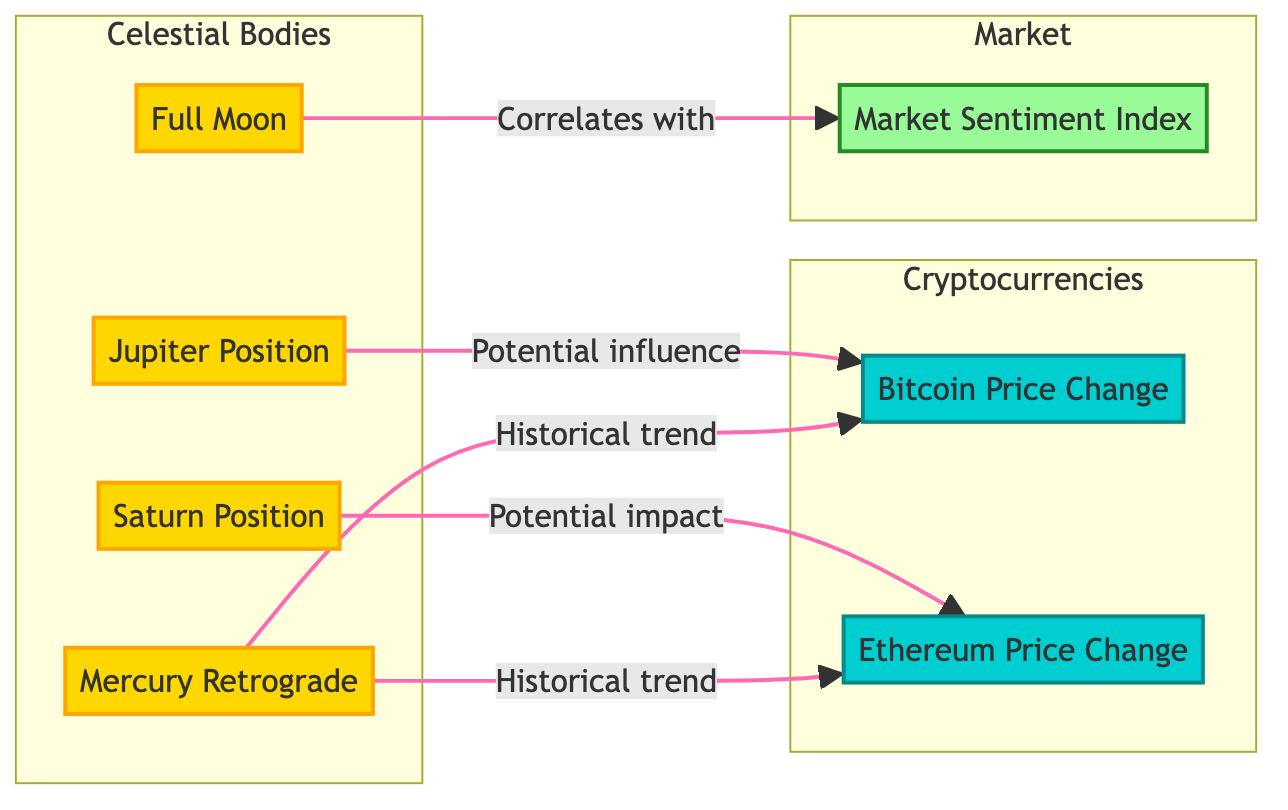What celestial body is linked to Bitcoin price change? The diagram shows an arrow from Jupiter Position to Bitcoin Price Change, indicating a potential influence.
Answer: Jupiter Position What is the major factor that correlates with the Market Sentiment Index? The diagram presents a correlation arrow from Full Moon to Market Sentiment Index, suggesting the relationship.
Answer: Full Moon How many celestial bodies are represented in the diagram? The diagram contains four distinct celestial bodies: Jupiter Position, Saturn Position, Full Moon, and Mercury Retrograde. Counting them gives a total of four.
Answer: Four What is the connection between Mercury Retrograde and cryptocurrencies in the diagram? The diagram illustrates arrows from Mercury Retrograde to both Bitcoin Price Change and Ethereum Price Change, signifying historical trends impacting both cryptocurrencies.
Answer: Historical trend Which planetary position potentially impacts Ethereum price change? An arrow in the diagram points from Saturn Position to Ethereum Price Change, indicating its potential impact.
Answer: Saturn Position What color represents the celestial bodies in the diagram? The diagram assigns a golden fill color to celestial bodies, as indicated by the class definition for celestial objects.
Answer: Golden Which cryptocurrency is influenced by Jupiter Position? In the diagram, the influence is directed specifically towards Bitcoin Price Change, as indicated by the connecting arrow.
Answer: Bitcoin Price Change What is the role of the Market Sentiment Index in this diagram? The Market Sentiment Index is connected to the Full Moon, suggesting it correlates with the lunar influence, as indicated by the connecting arrow.
Answer: Correlates with How many nodes represent cryptocurrencies in the diagram? The diagram identifies two cryptocurrency nodes, Bitcoin Price Change and Ethereum Price Change, confirming the total count.
Answer: Two 